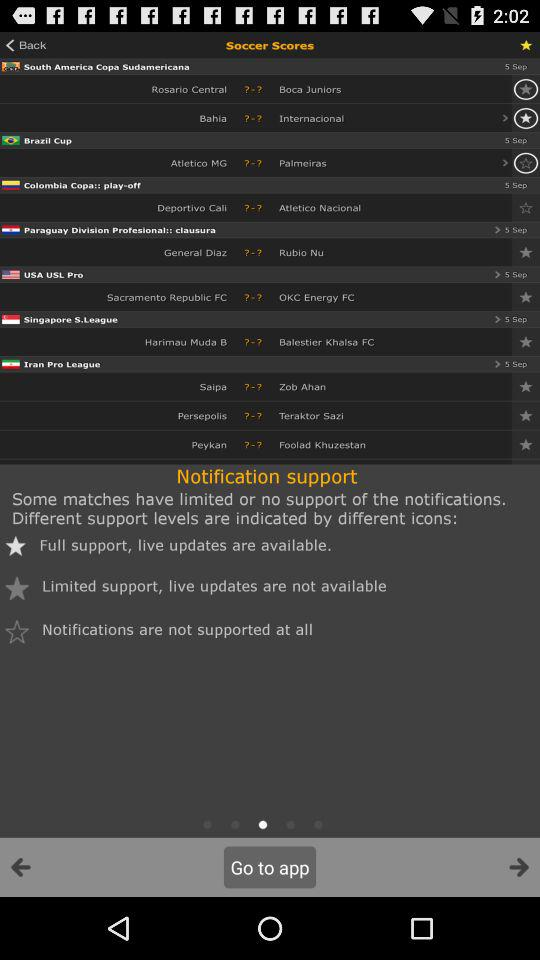How many matches have limited support for notifications?
Answer the question using a single word or phrase. 1 